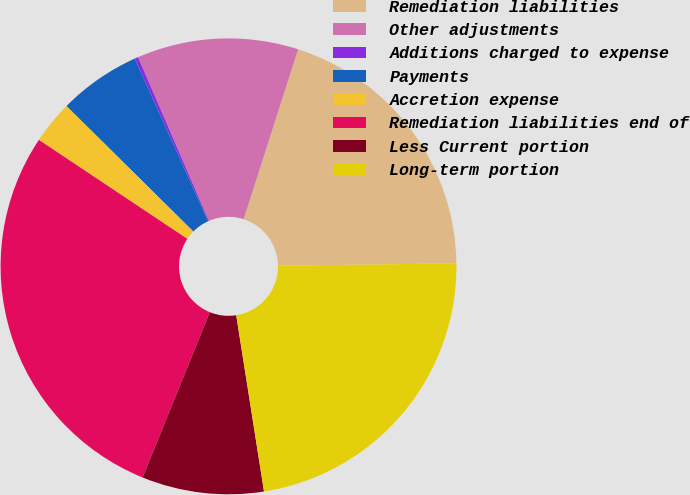<chart> <loc_0><loc_0><loc_500><loc_500><pie_chart><fcel>Remediation liabilities<fcel>Other adjustments<fcel>Additions charged to expense<fcel>Payments<fcel>Accretion expense<fcel>Remediation liabilities end of<fcel>Less Current portion<fcel>Long-term portion<nl><fcel>19.85%<fcel>11.44%<fcel>0.25%<fcel>5.84%<fcel>3.05%<fcel>28.21%<fcel>8.64%<fcel>22.72%<nl></chart> 